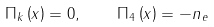Convert formula to latex. <formula><loc_0><loc_0><loc_500><loc_500>\Pi _ { k } \left ( x \right ) = 0 , \quad \Pi _ { 4 } \left ( x \right ) = - n _ { e }</formula> 